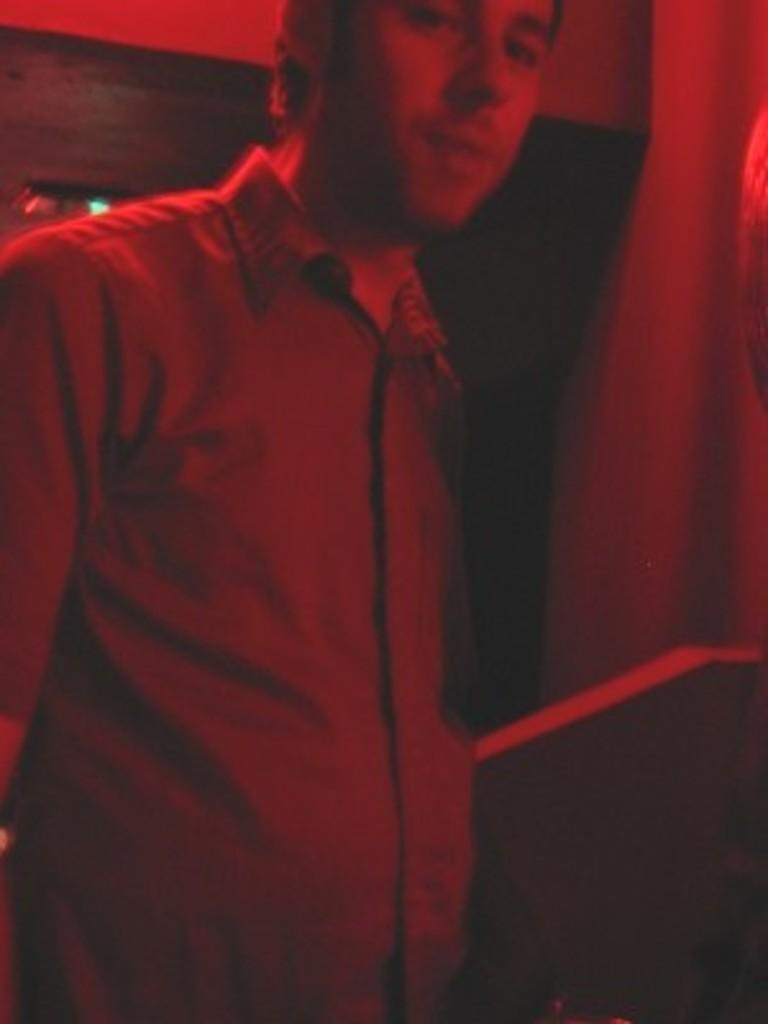Who is present in the image? There is a man in the image. What is the man doing in the image? The man is standing in the image. What is the man wearing in the image? The man is wearing a shirt in the image. What can be observed about the lighting in the image? There is a red color light focused on the man in the image. How many dogs are present in the image? There are no dogs present in the image. What type of locket is the man wearing in the image? The man is not wearing a locket in the image. 